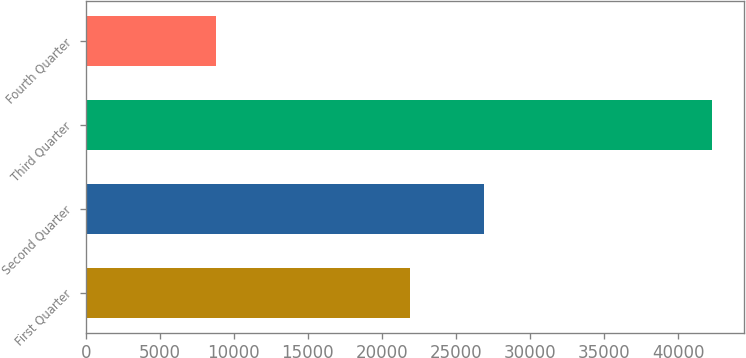<chart> <loc_0><loc_0><loc_500><loc_500><bar_chart><fcel>First Quarter<fcel>Second Quarter<fcel>Third Quarter<fcel>Fourth Quarter<nl><fcel>21880<fcel>26913<fcel>42279<fcel>8807<nl></chart> 